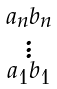<formula> <loc_0><loc_0><loc_500><loc_500>\begin{smallmatrix} a _ { n } b _ { n } \\ \vdots \\ a _ { 1 } b _ { 1 } \end{smallmatrix}</formula> 